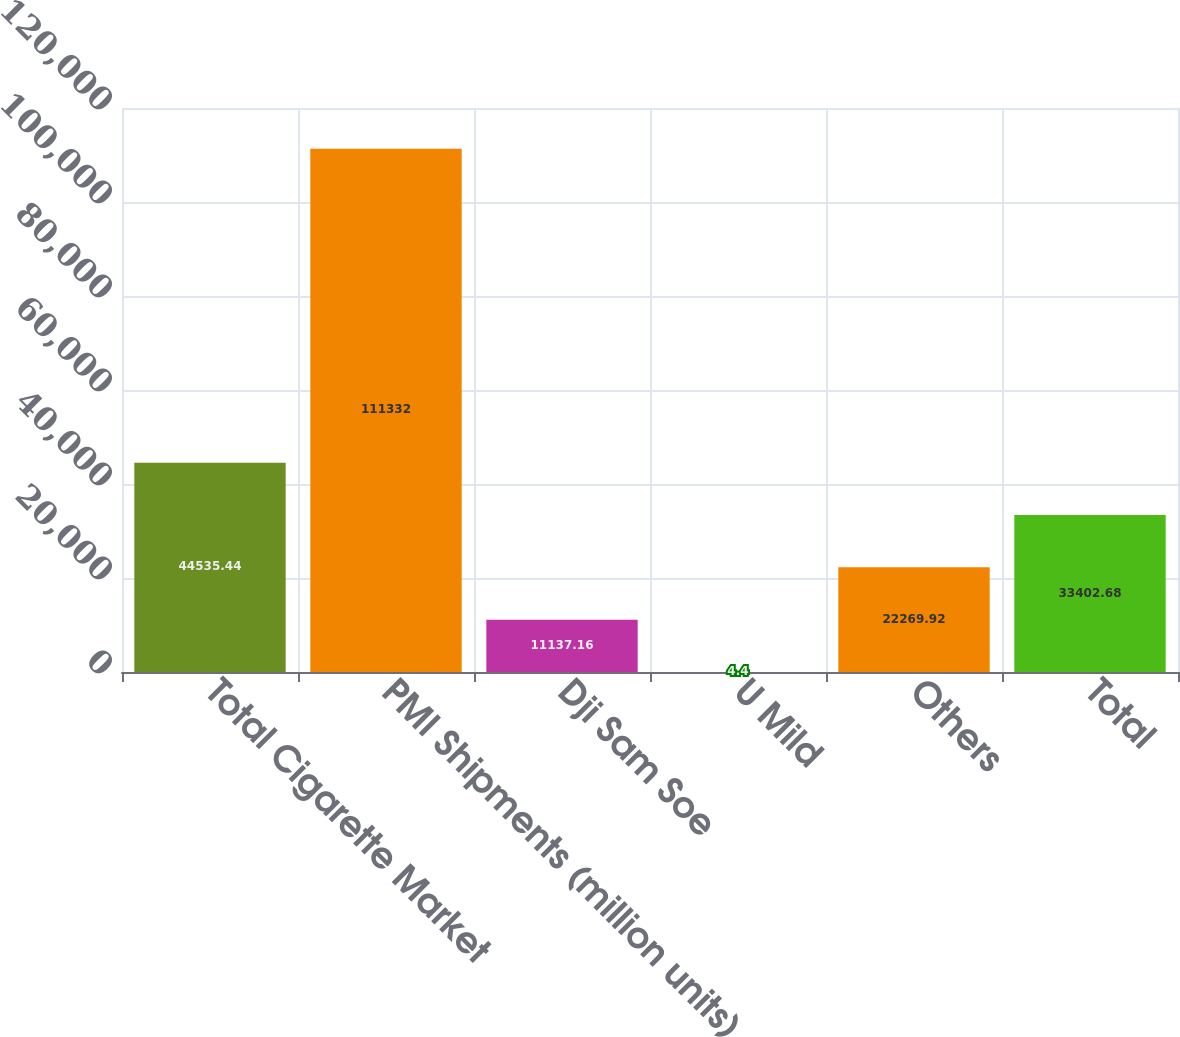<chart> <loc_0><loc_0><loc_500><loc_500><bar_chart><fcel>Total Cigarette Market<fcel>PMI Shipments (million units)<fcel>Dji Sam Soe<fcel>U Mild<fcel>Others<fcel>Total<nl><fcel>44535.4<fcel>111332<fcel>11137.2<fcel>4.4<fcel>22269.9<fcel>33402.7<nl></chart> 